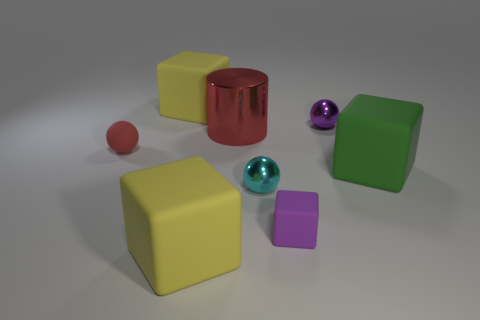Subtract 1 cubes. How many cubes are left? 3 Add 2 red balls. How many objects exist? 10 Subtract all balls. How many objects are left? 5 Add 1 tiny green metallic cubes. How many tiny green metallic cubes exist? 1 Subtract 0 blue cubes. How many objects are left? 8 Subtract all big cyan balls. Subtract all red objects. How many objects are left? 6 Add 7 large yellow things. How many large yellow things are left? 9 